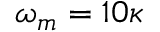Convert formula to latex. <formula><loc_0><loc_0><loc_500><loc_500>\omega _ { m } = 1 0 \kappa</formula> 